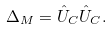Convert formula to latex. <formula><loc_0><loc_0><loc_500><loc_500>\Delta _ { M } = \hat { U } _ { C } \hat { U } _ { C } .</formula> 